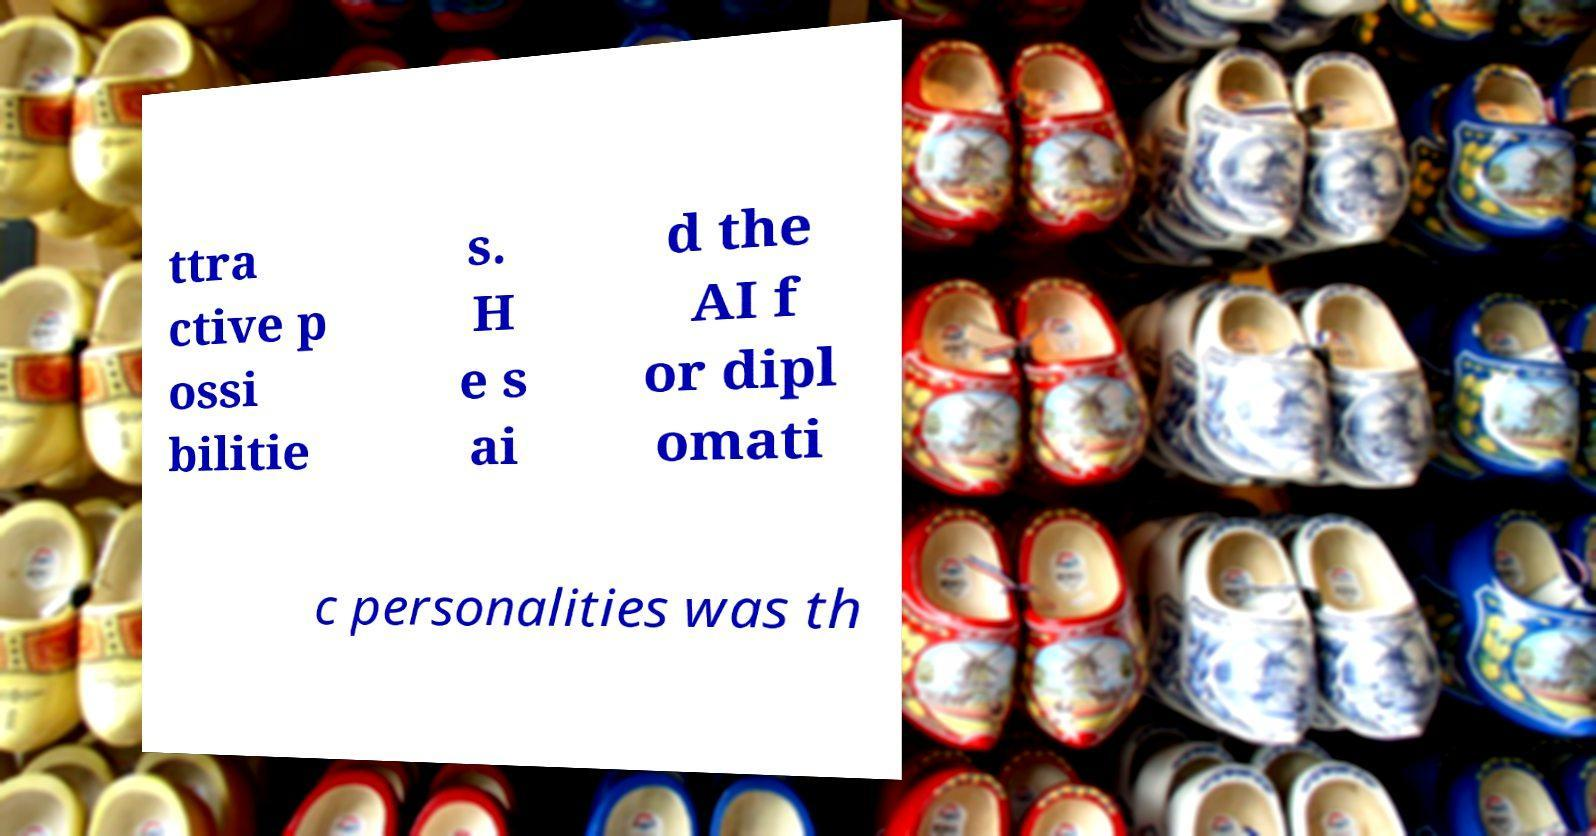Can you accurately transcribe the text from the provided image for me? ttra ctive p ossi bilitie s. H e s ai d the AI f or dipl omati c personalities was th 